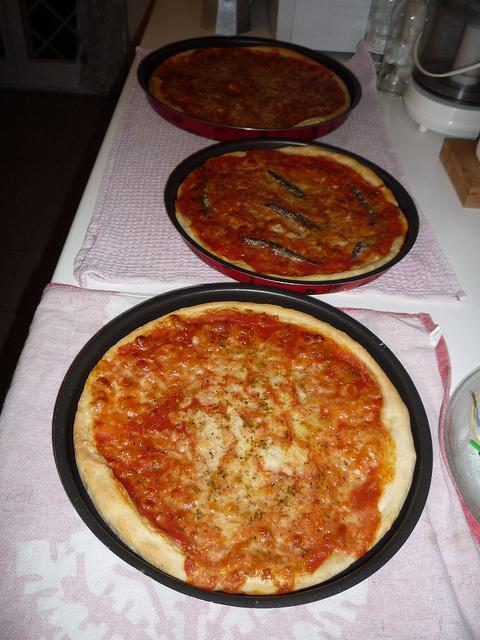What is the largest pizza on top of?

Choices:
A) wooden board
B) paper plate
C) aluminum tray
D) tray tray 